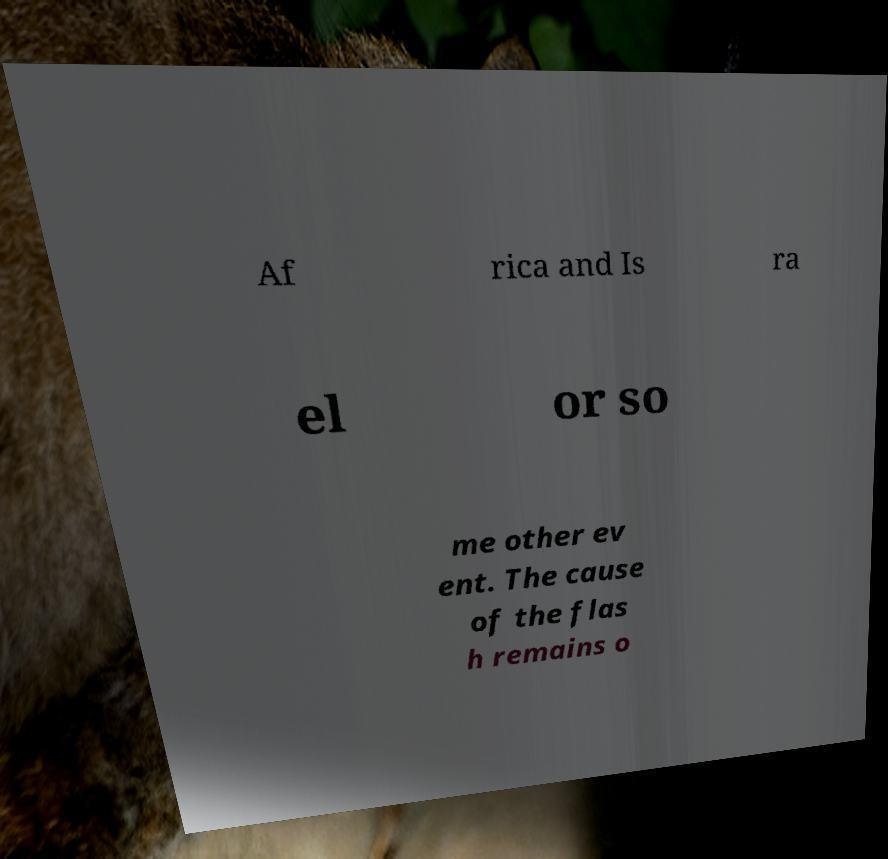I need the written content from this picture converted into text. Can you do that? Af rica and Is ra el or so me other ev ent. The cause of the flas h remains o 